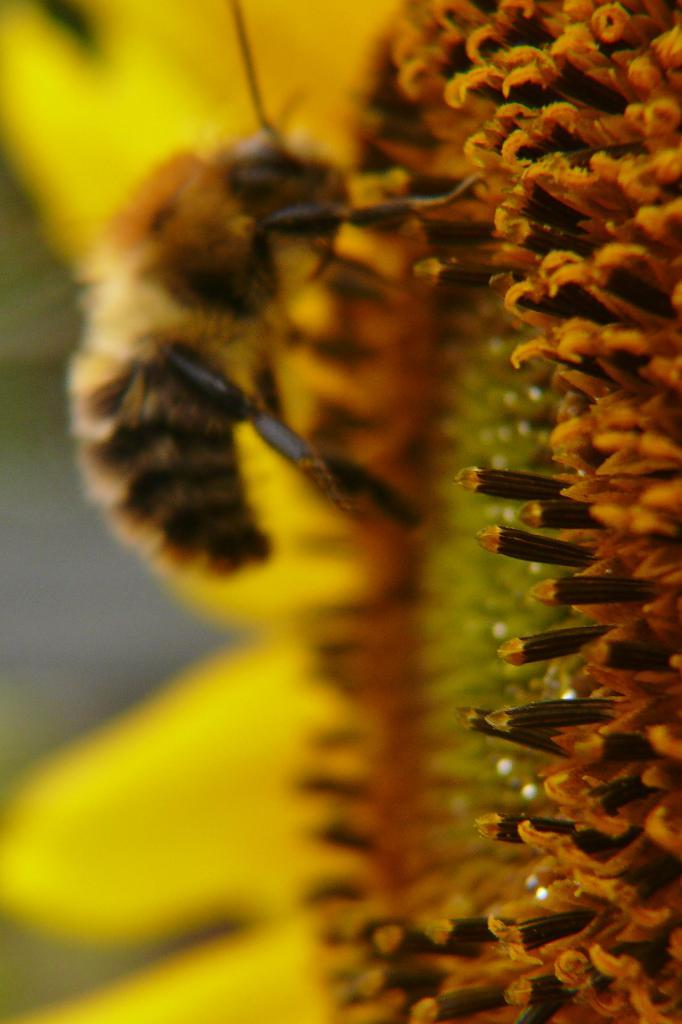What is the main subject in the center of the image? There is a flower in the center of the image. Is there anything else present on the flower? Yes, there is a bee on the flower. What type of place is depicted in the image? The image does not depict a specific place; it features a flower with a bee on it. Can you tell me how many yaks are visible in the image? There are no yaks present in the image. 